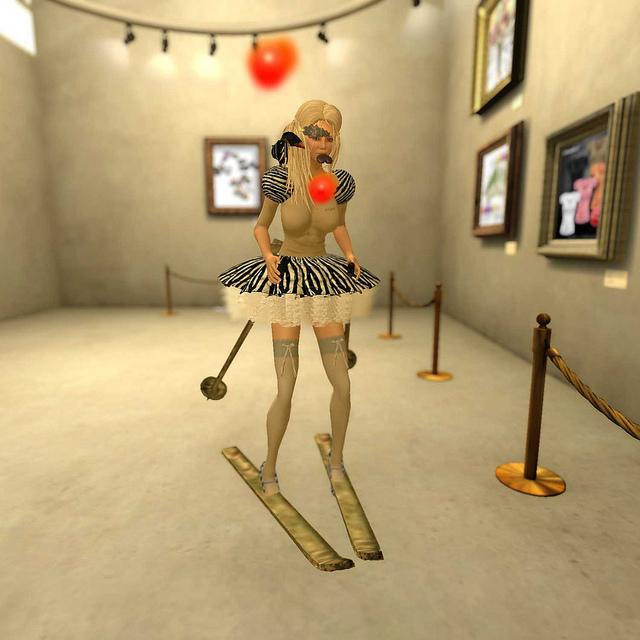What are on the wall?
Short answer required. Pictures. Is the subject wearing ski shoes?
Write a very short answer. Yes. Is this a real person?
Short answer required. No. 